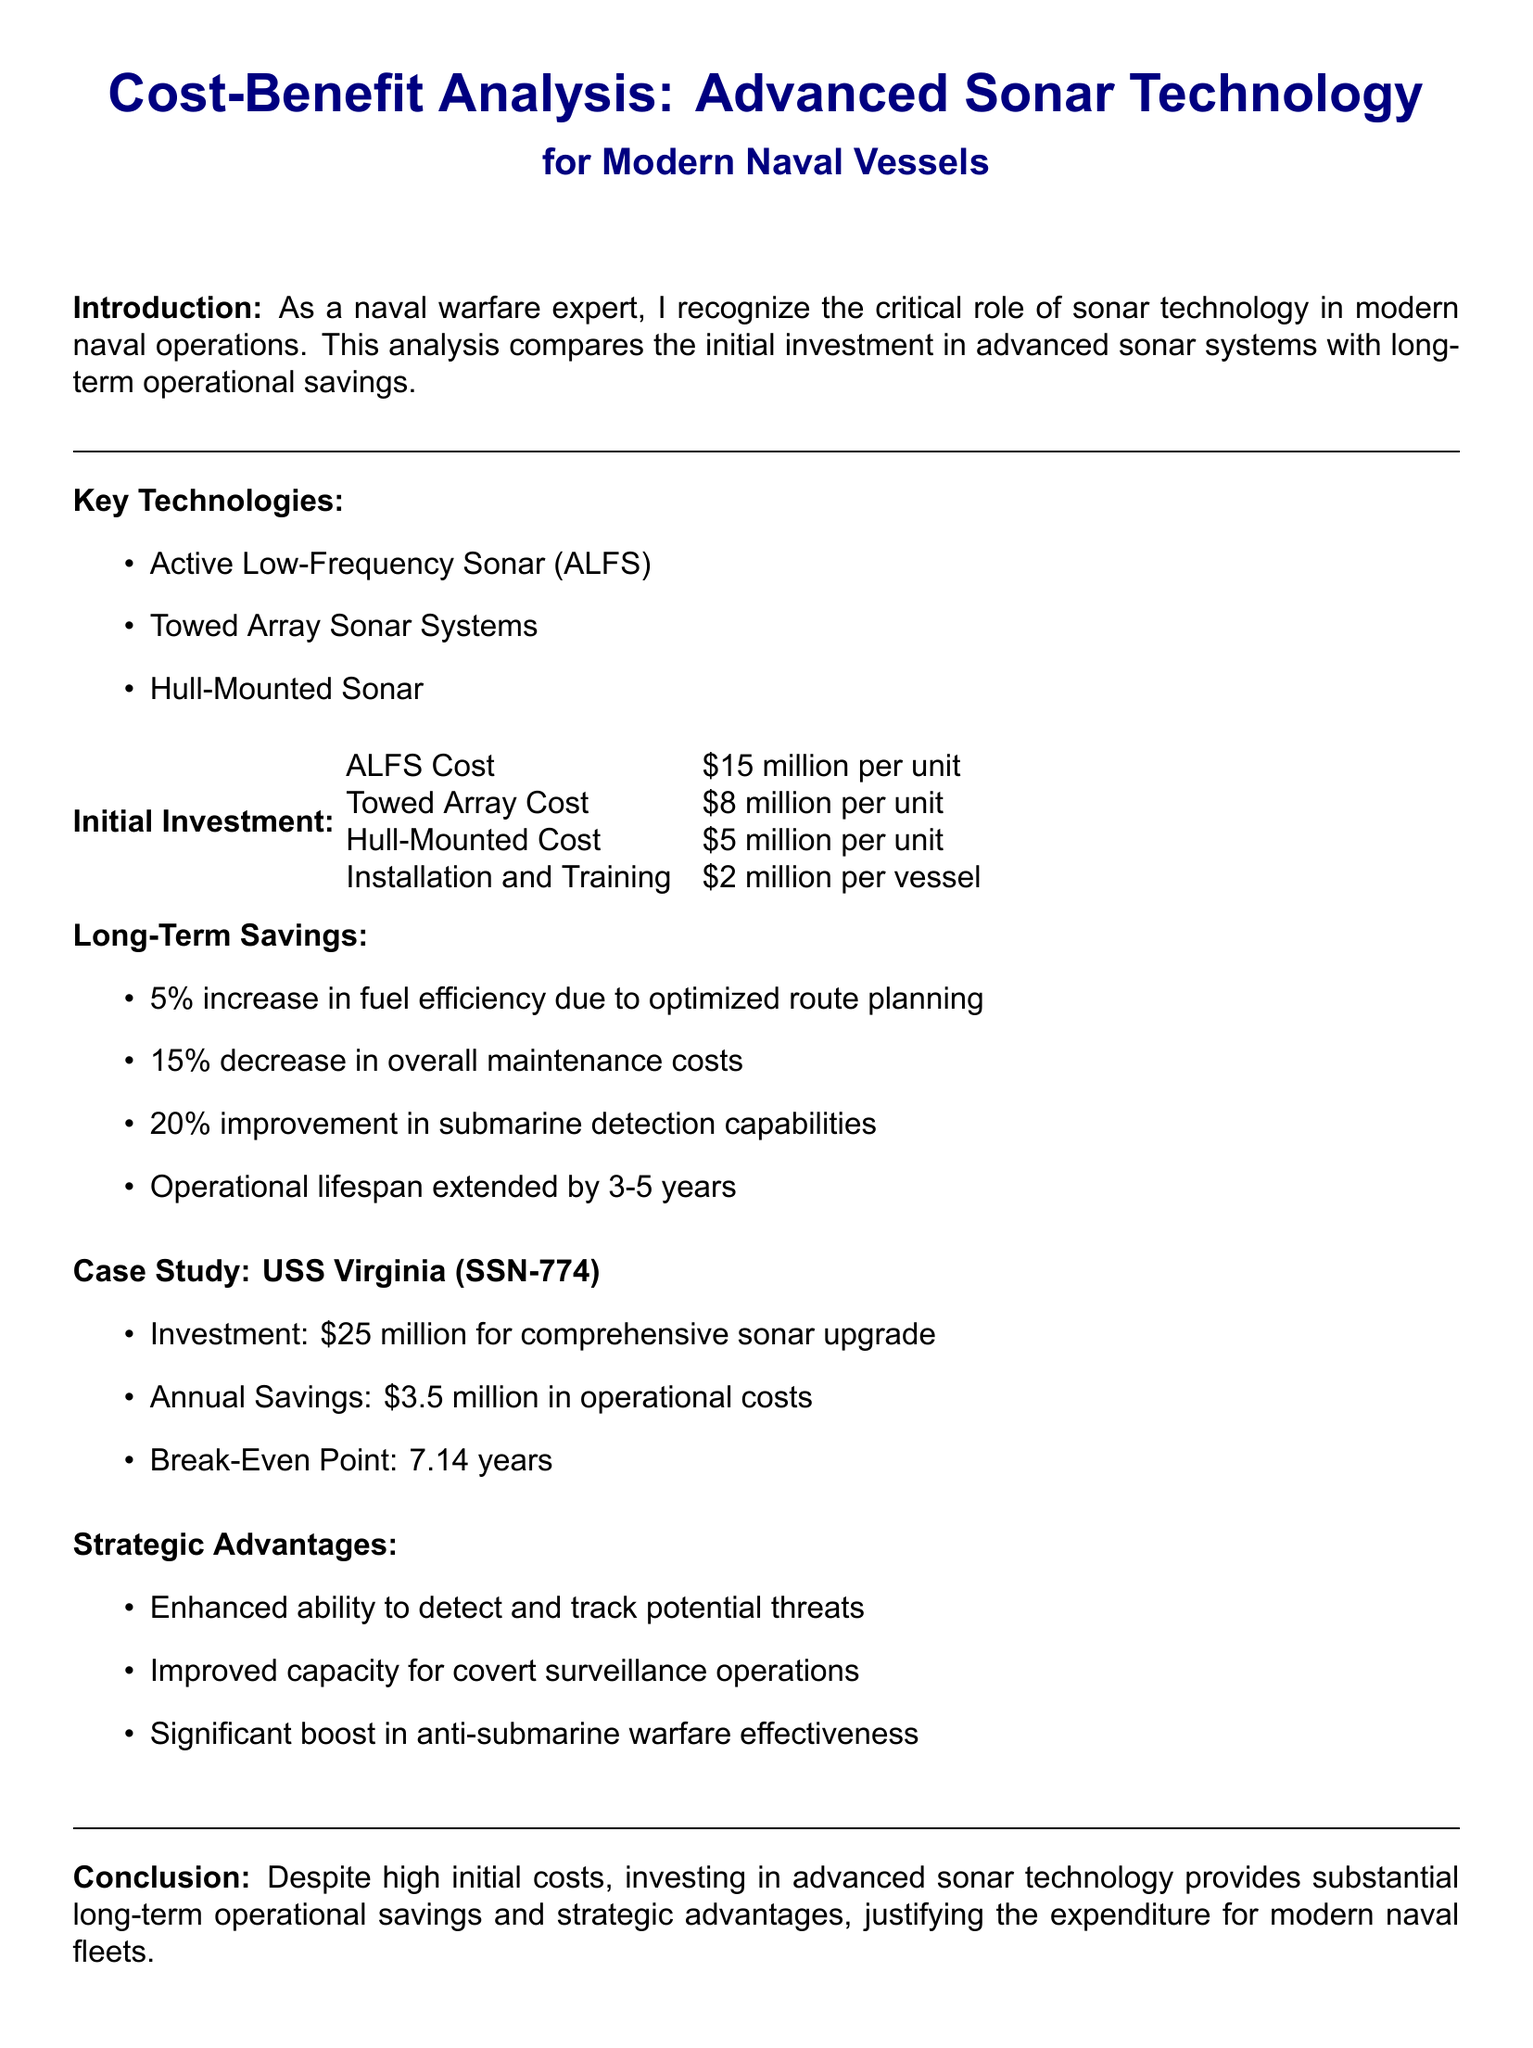What is the cost of ALFS per unit? The document specifies that the ALFS costs $15 million per unit.
Answer: $15 million per unit What is the annual savings from the USS Virginia upgrade? According to the case study, the annual savings from the comprehensive sonar upgrade on USS Virginia is $3.5 million.
Answer: $3.5 million What is the break-even point for the investment? The break-even point for the investment in advanced sonar technology is stated as 7.14 years.
Answer: 7.14 years By what percentage does maintenance costs decrease? The analysis indicates that there is a 15% decrease in overall maintenance costs.
Answer: 15% What operational advantage is improved due to advanced sonar technology? The technology provides a 20% improvement in submarine detection capabilities.
Answer: 20% What is the installation and training cost per vessel? The document lists the installation and training cost as $2 million per vessel.
Answer: $2 million per vessel How long is the operational lifespan extended by the technology? The analysis mentions that the operational lifespan is extended by 3-5 years.
Answer: 3-5 years What key technology is mentioned first in the introduction? The first key technology mentioned in the introduction is Active Low-Frequency Sonar (ALFS).
Answer: Active Low-Frequency Sonar (ALFS) What is the total initial investment for comprehensive sonar upgrade on USS Virginia? The document states that the total investment for the sonar upgrade on USS Virginia is $25 million.
Answer: $25 million 